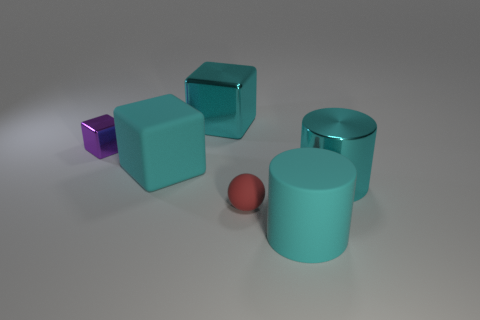How many other things are there of the same color as the metallic cylinder?
Your answer should be very brief. 3. The cyan cube that is made of the same material as the small purple block is what size?
Make the answer very short. Large. What material is the large cylinder in front of the cyan shiny object in front of the tiny purple block behind the tiny red matte sphere?
Offer a very short reply. Rubber. Are there fewer cyan objects than cyan metallic things?
Make the answer very short. No. Is the material of the ball the same as the purple cube?
Give a very brief answer. No. There is a large metallic object that is the same color as the big metal cube; what shape is it?
Your answer should be very brief. Cylinder. There is a big rubber object that is right of the red rubber object; does it have the same color as the metallic cylinder?
Provide a short and direct response. Yes. How many small balls are on the right side of the cyan cylinder that is on the right side of the large rubber cylinder?
Make the answer very short. 0. There is a rubber thing that is the same size as the purple block; what is its color?
Offer a very short reply. Red. What is the material of the cyan object in front of the small red rubber sphere?
Offer a very short reply. Rubber. 